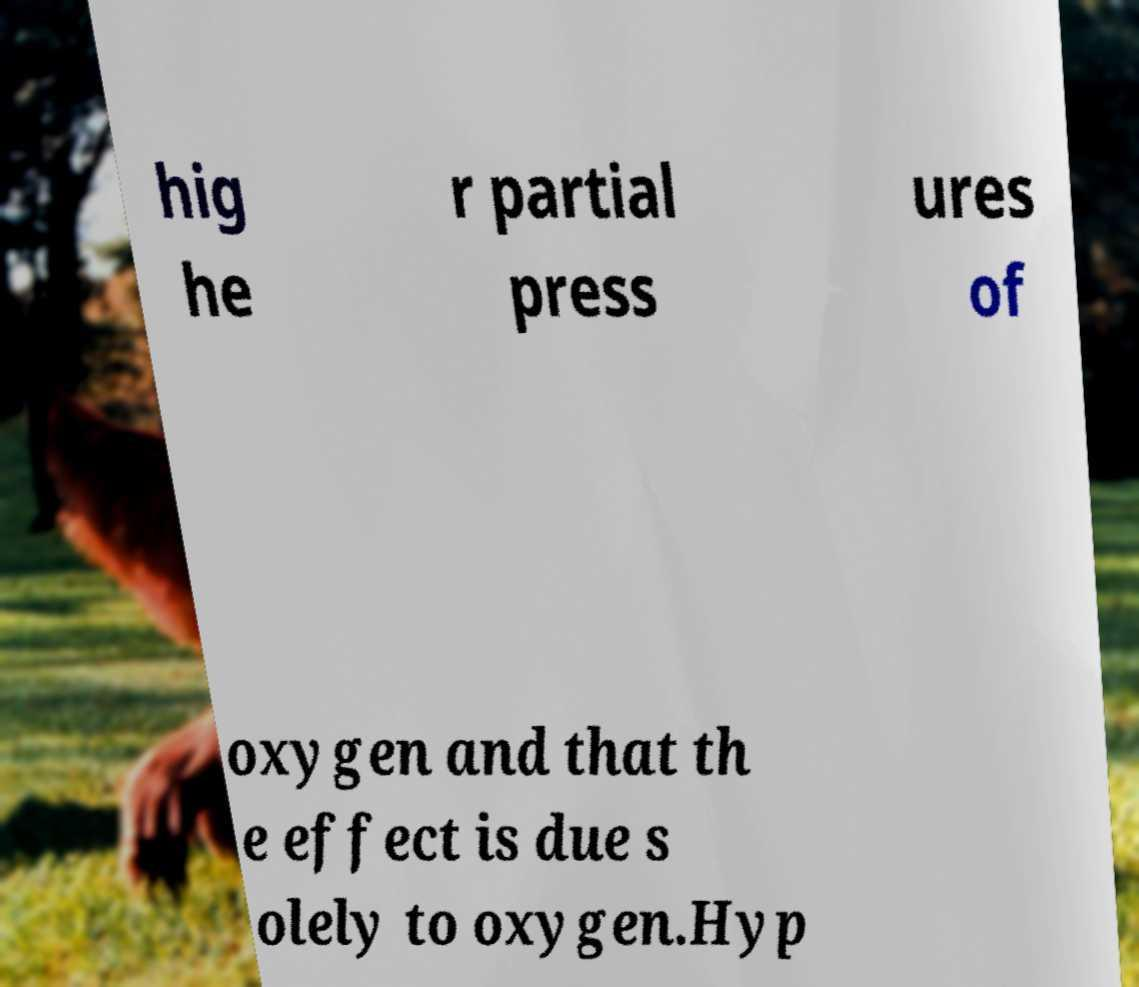What messages or text are displayed in this image? I need them in a readable, typed format. hig he r partial press ures of oxygen and that th e effect is due s olely to oxygen.Hyp 